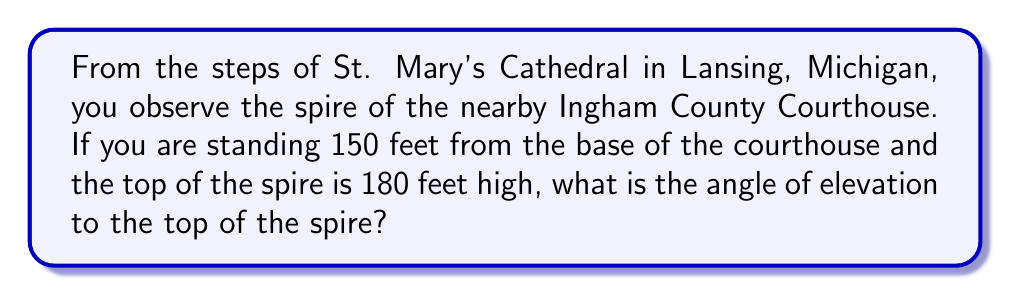Provide a solution to this math problem. To solve this problem, we'll use trigonometry, specifically the tangent function. Let's approach this step-by-step:

1) First, let's visualize the problem:

[asy]
import geometry;

pair A = (0,0);
pair B = (150,0);
pair C = (150,180);

draw(A--B--C--A);

label("150 ft", (75,0), S);
label("180 ft", (150,90), E);
label("θ", (0,0), NW);

dot("A", A, SW);
dot("B", B, SE);
dot("C", C, NE);
[/asy]

2) In this right triangle, we know:
   - The adjacent side (distance from observer to base of courthouse) = 150 feet
   - The opposite side (height of the spire) = 180 feet
   - We need to find the angle θ

3) The tangent of an angle in a right triangle is the ratio of the opposite side to the adjacent side:

   $$\tan(\theta) = \frac{\text{opposite}}{\text{adjacent}} = \frac{180}{150}$$

4) To find θ, we need to use the inverse tangent (arctan or tan^(-1)):

   $$\theta = \tan^{-1}(\frac{180}{150})$$

5) Using a calculator or computer:

   $$\theta = \tan^{-1}(1.2) \approx 50.19°$$

6) Round to the nearest degree:

   $$\theta \approx 50°$$
Answer: 50° 